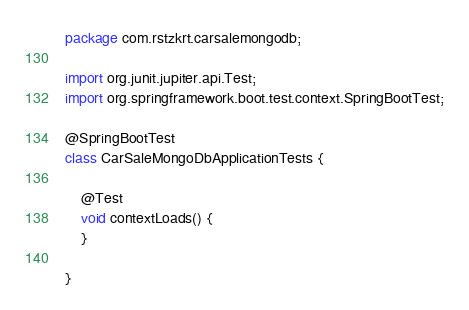Convert code to text. <code><loc_0><loc_0><loc_500><loc_500><_Java_>package com.rstzkrt.carsalemongodb;

import org.junit.jupiter.api.Test;
import org.springframework.boot.test.context.SpringBootTest;

@SpringBootTest
class CarSaleMongoDbApplicationTests {

    @Test
    void contextLoads() {
    }

}
</code> 